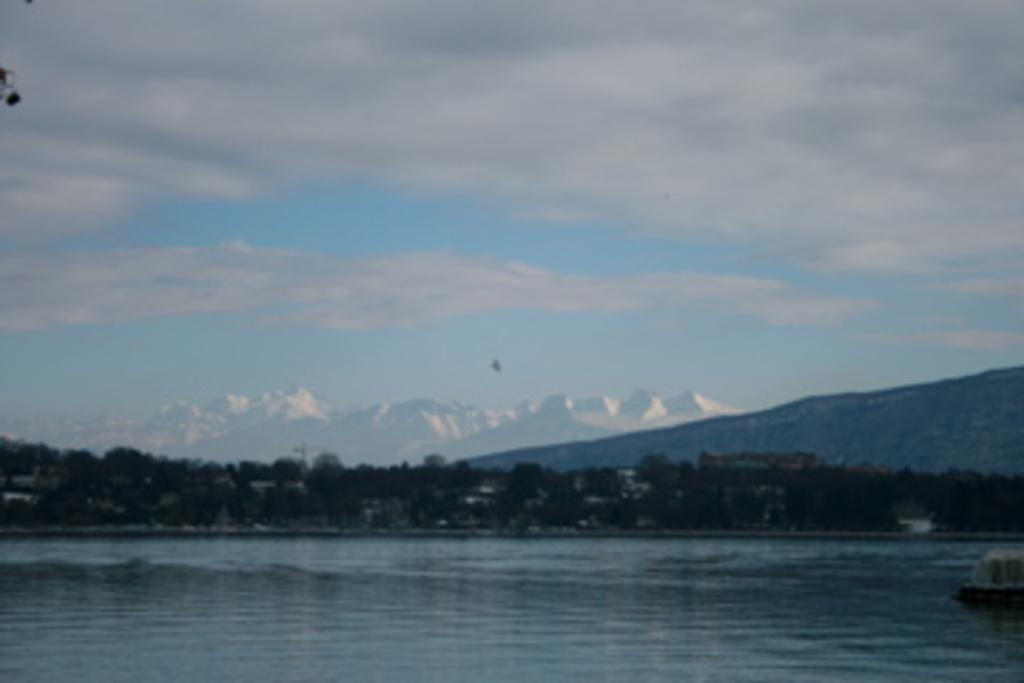What is present at the bottom of the image? There is water at the bottom of the image. What can be seen in the middle of the image? There is a tree in the middle of the image. What is visible in the background of the image? The sky is visible in the background of the image. What type of shirt is hanging on the tree in the image? There is no shirt present in the image; it features water, a tree, and the sky. How many pigs can be seen playing in the water at the bottom of the image? There are no pigs present in the image; it only features water, a tree, and the sky. 